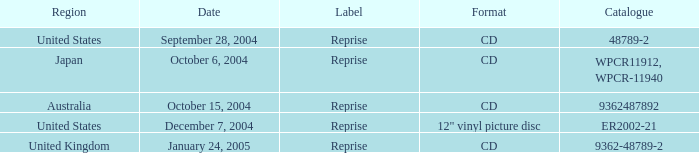What is the directory on october 15, 2004? 9362487892.0. 